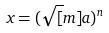Convert formula to latex. <formula><loc_0><loc_0><loc_500><loc_500>x = ( \sqrt { [ } m ] { a } ) ^ { n }</formula> 